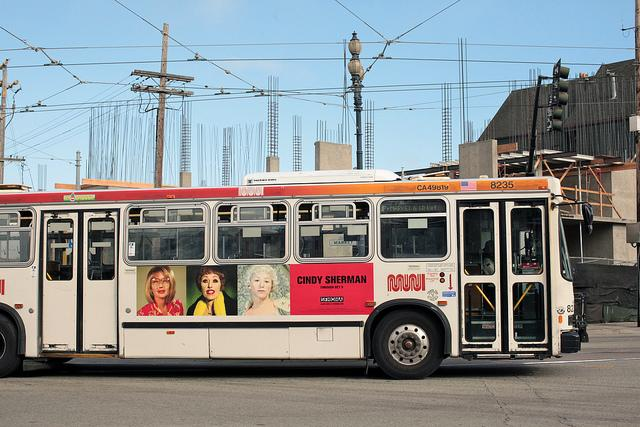What is on the side of the bus? advertisement 